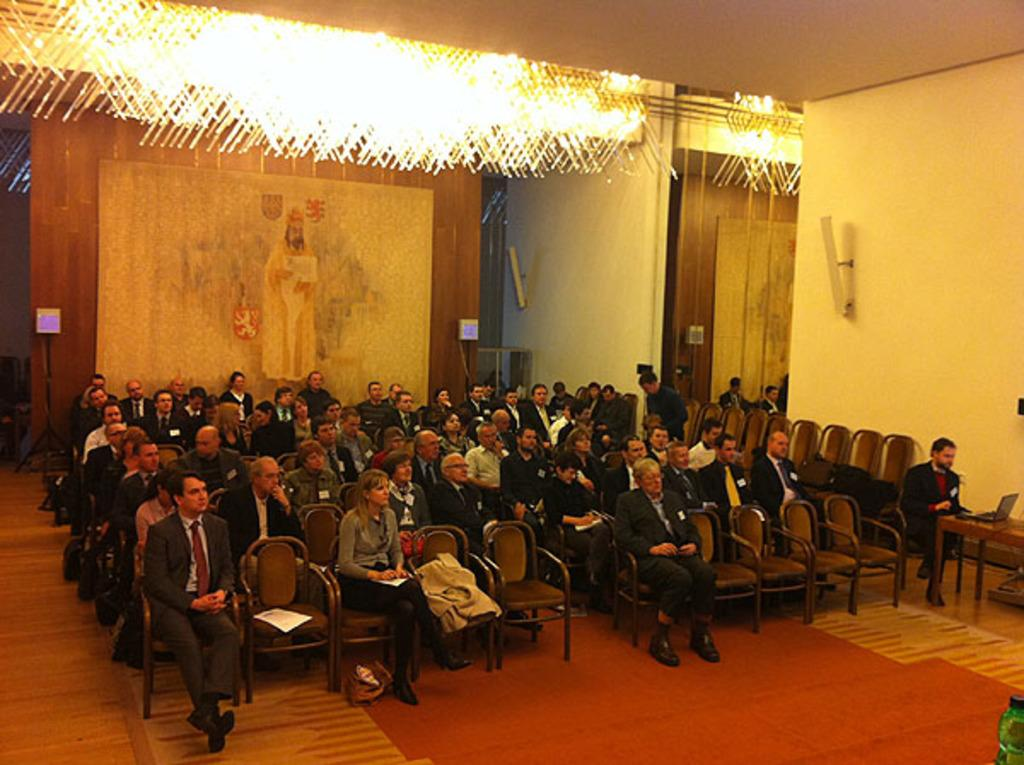What can be seen on the wall in the room? There is a wall with a frame in the room. Can you describe the lighting in the image? Yes, there are lights visible at the top of the image. Is there a dock visible in the image? No, there is no dock present in the image. What type of furniture is the ghost sitting on in the image? There is no ghost present in the image, so it is not possible to answer that question. 